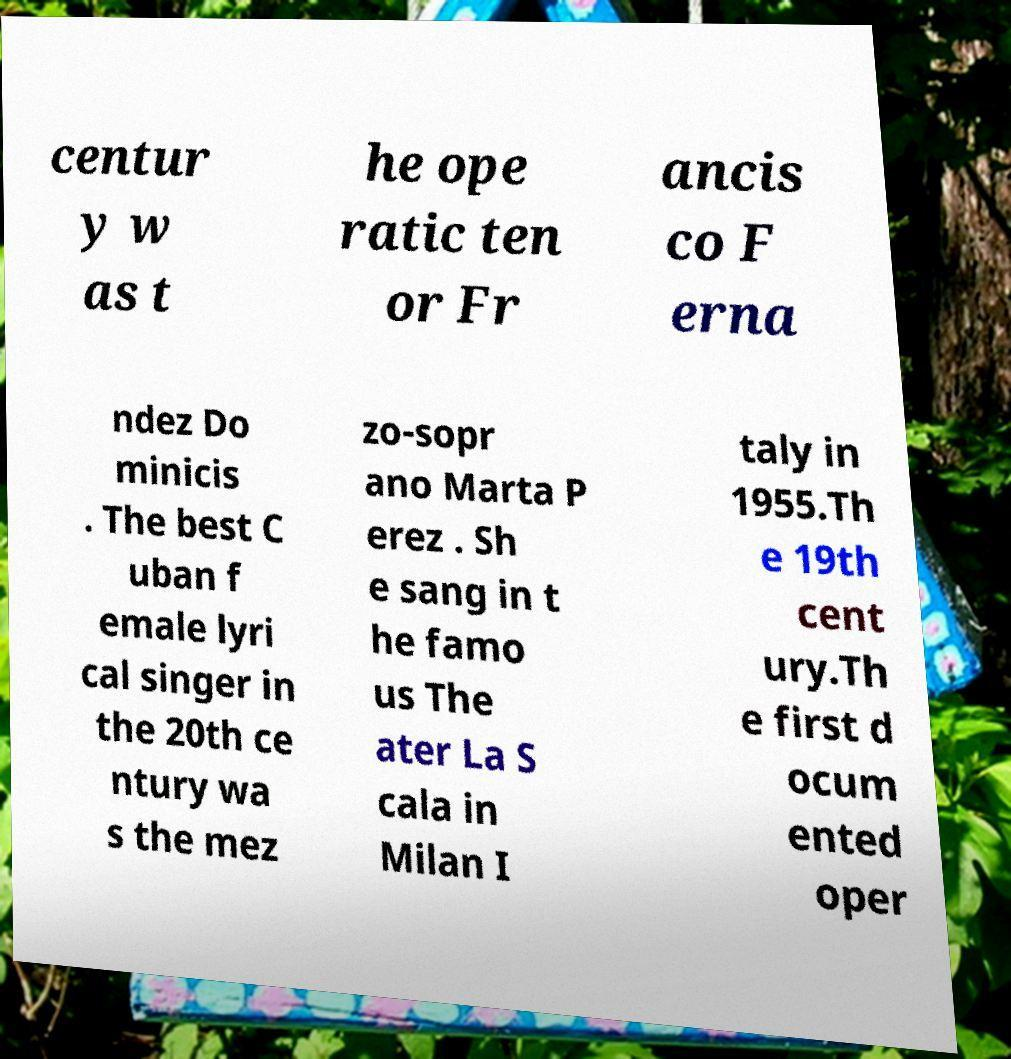There's text embedded in this image that I need extracted. Can you transcribe it verbatim? centur y w as t he ope ratic ten or Fr ancis co F erna ndez Do minicis . The best C uban f emale lyri cal singer in the 20th ce ntury wa s the mez zo-sopr ano Marta P erez . Sh e sang in t he famo us The ater La S cala in Milan I taly in 1955.Th e 19th cent ury.Th e first d ocum ented oper 